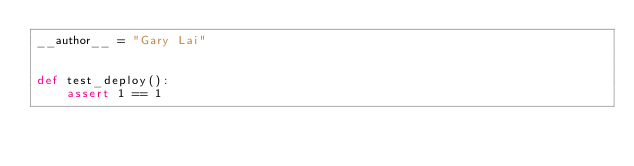Convert code to text. <code><loc_0><loc_0><loc_500><loc_500><_Python_>__author__ = "Gary Lai"


def test_deploy():
    assert 1 == 1
</code> 